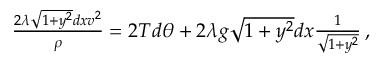<formula> <loc_0><loc_0><loc_500><loc_500>\begin{array} { r } { \frac { 2 \lambda \sqrt { 1 + y ^ { 2 } } d x v ^ { 2 } } { \rho } = 2 T d \theta + 2 \lambda g \sqrt { 1 + y ^ { 2 } } d x \frac { 1 } { \sqrt { 1 + y ^ { 2 } } } \, , } \end{array}</formula> 